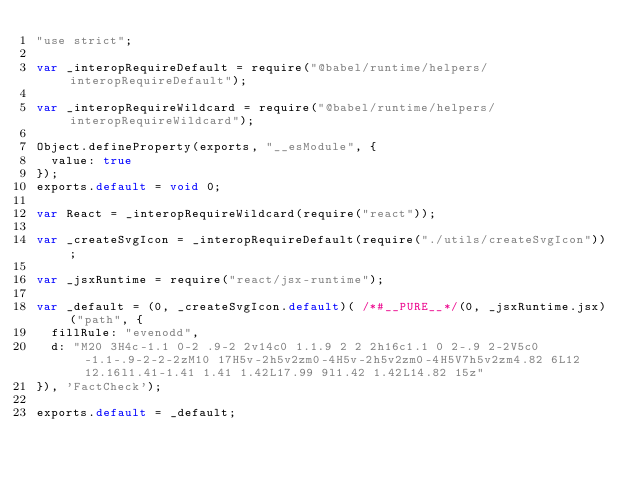Convert code to text. <code><loc_0><loc_0><loc_500><loc_500><_JavaScript_>"use strict";

var _interopRequireDefault = require("@babel/runtime/helpers/interopRequireDefault");

var _interopRequireWildcard = require("@babel/runtime/helpers/interopRequireWildcard");

Object.defineProperty(exports, "__esModule", {
  value: true
});
exports.default = void 0;

var React = _interopRequireWildcard(require("react"));

var _createSvgIcon = _interopRequireDefault(require("./utils/createSvgIcon"));

var _jsxRuntime = require("react/jsx-runtime");

var _default = (0, _createSvgIcon.default)( /*#__PURE__*/(0, _jsxRuntime.jsx)("path", {
  fillRule: "evenodd",
  d: "M20 3H4c-1.1 0-2 .9-2 2v14c0 1.1.9 2 2 2h16c1.1 0 2-.9 2-2V5c0-1.1-.9-2-2-2zM10 17H5v-2h5v2zm0-4H5v-2h5v2zm0-4H5V7h5v2zm4.82 6L12 12.16l1.41-1.41 1.41 1.42L17.99 9l1.42 1.42L14.82 15z"
}), 'FactCheck');

exports.default = _default;</code> 